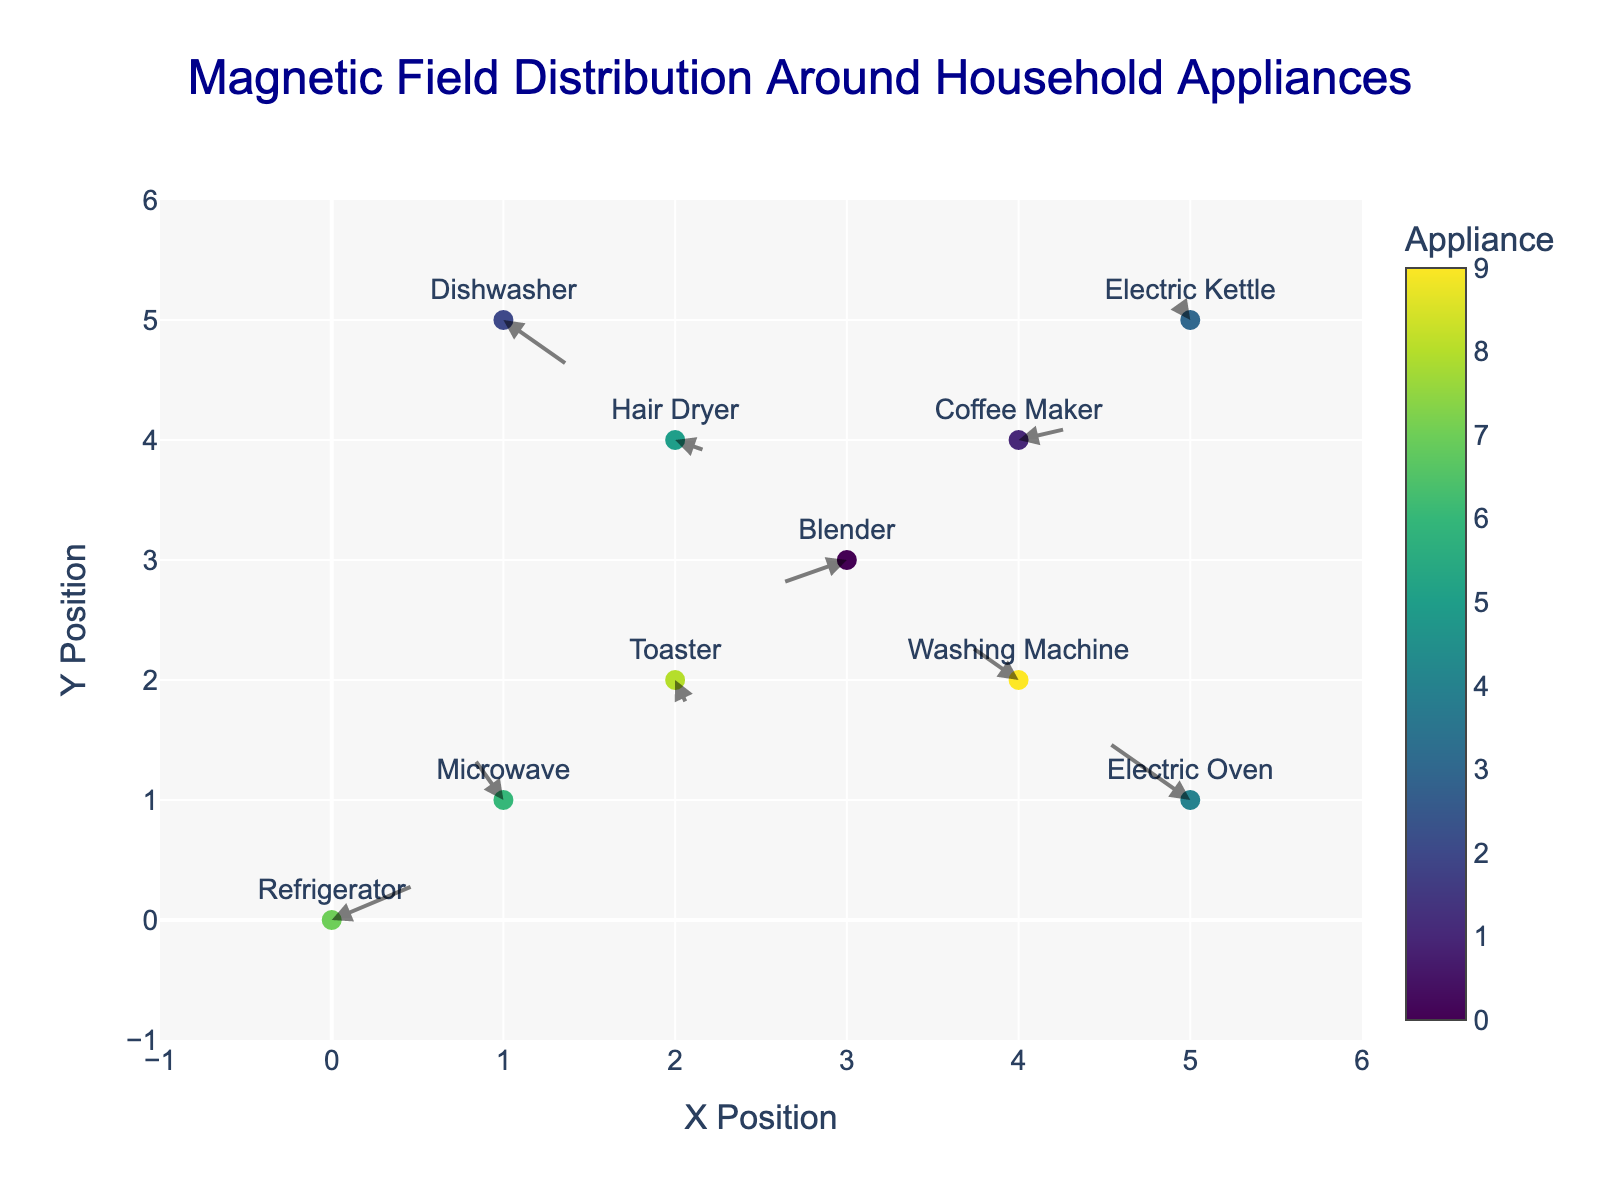What's the title of this plot? The title is displayed at the top of the plot in a larger font size and different color. It reads "Magnetic Field Distribution Around Household Appliances".
Answer: Magnetic Field Distribution Around Household Appliances What do the arrows in the plot represent? The arrows show the direction and magnitude of the magnetic fields around each household appliance. Each arrow starts at a data point corresponding to a specific appliance and points in the direction of the magnetic field, indicating both its direction and strength.
Answer: The direction and strength of the magnetic fields What appliance demonstrates the largest magnetic field vector? By examining the plot, the length and direction of the arrows indicate the magnitude and direction of the magnetic fields. The Dishwasher has the largest arrow, signifying the largest magnetic field vector.
Answer: Dishwasher How many appliances produce a magnetic field in the negative x or y direction? To determine this, look at the arrows pointing towards the negative direction on the x or y axes. Arrows related to Microwave, Blender, Washing Machine, and Electric Oven point negatively, either in x or y directions.
Answer: Four appliances Which appliance has a magnetic field vector pointing in both negative x and negative y directions? From the plot, we observe the arrows direction for each appliance. The Blender’s arrow points in both the negative x and y directions.
Answer: Blender For the Blender, what are the x and y coordinates and the corresponding magnetic field components? By locating the Blender on the plot, we find it at (3, 3). The components of its magnetic field are displayed by its arrow, which points (-0.4, -0.2).
Answer: (3, 3), with components (-0.4, -0.2) Compare the magnetic field directions of the Refrigerator and the Coffee Maker. How do they differ? The plot shows the Refrigerator has an arrow pointing in the direction of (0.5, 0.3) while the Coffee Maker’s arrow points towards (0.3, 0.1). Both are in the positive x and y directions, but the Refrigerator has a stronger magnetic field along both axes.
Answer: Both point positively, but the Refrigerator has a stronger magnetic field Which appliance has the smallest magnetic field vector, and what are its components? Observing the lengths of the arrows, the Toaster has the shortest arrow, indicating the smallest magnetic field vector. Its components are (0.1, -0.3).
Answer: Toaster, (0.1, -0.3) Identify the appliance with the arrow pointing furthest upwards and state its y-component. The arrow pointing furthest upwards can be identified by checking the y-components. The Microwave’s arrow has the highest positive y-component of 0.4.
Answer: Microwave, 0.4 